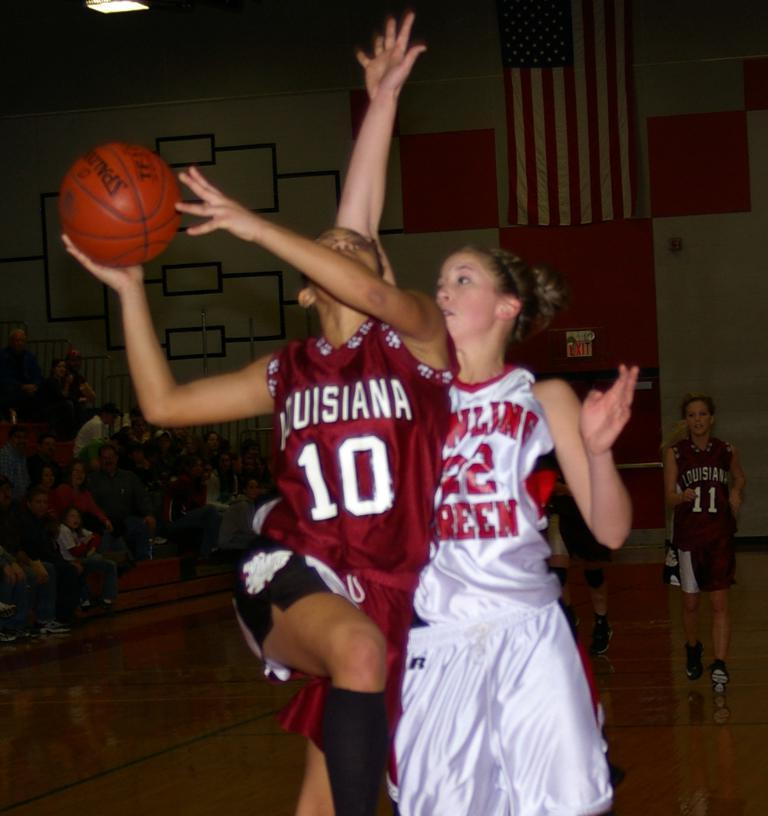<image>
Create a compact narrative representing the image presented. A basketball player has the number 10 on her jersey. 